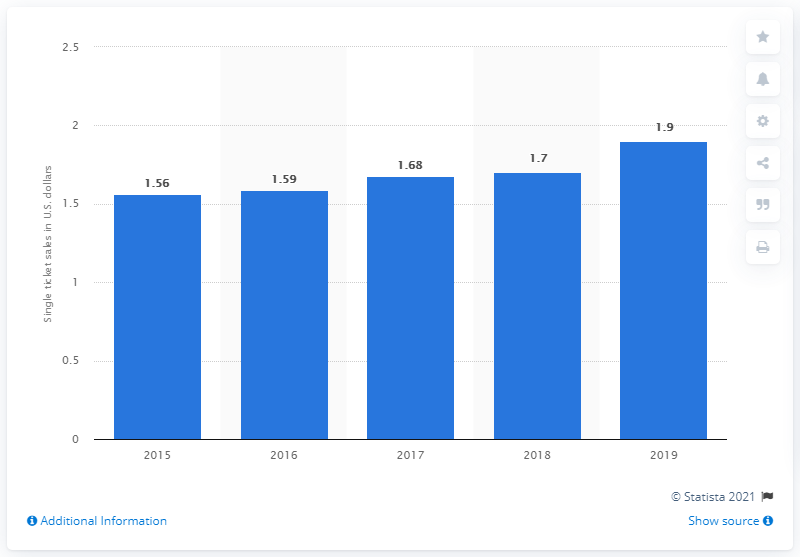Highlight a few significant elements in this photo. In the year 2019, the average single ticket income increased significantly. In the United States in 2019, the average single ticket income was 1.9 million dollars. 